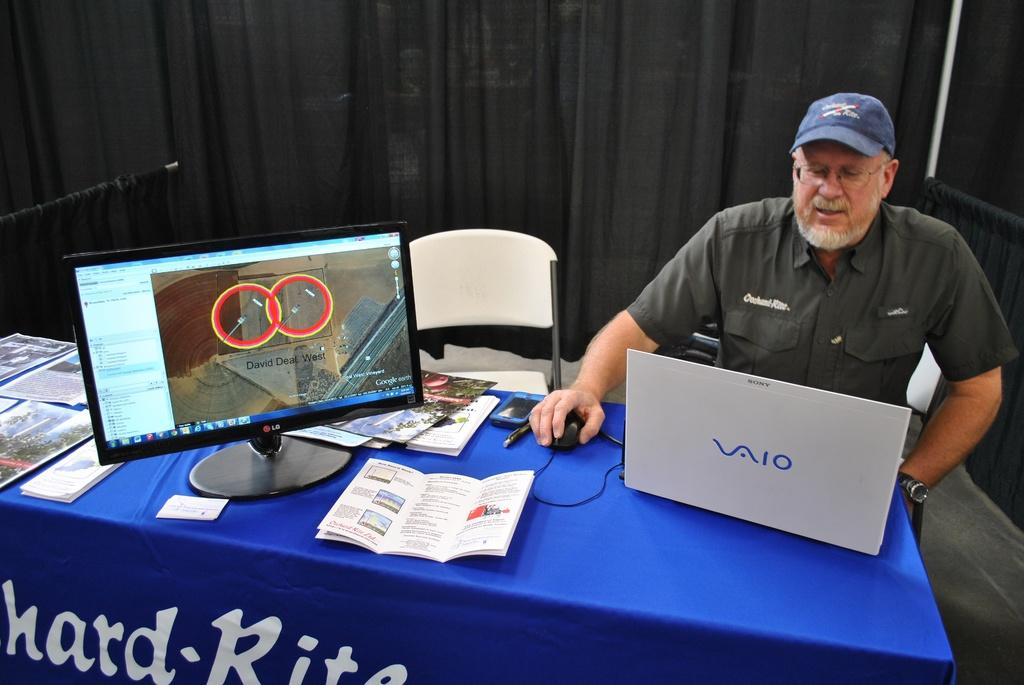What is the person in the image doing? The person is sitting on a chair. What can be seen on the person's head? The person is wearing a cap. What is in front of the person? There is a table in front of the person. What electronic devices are on the table? There is a laptop and a monitor on the table. What writing materials are on the table? There is a paper and a pen on the table. What communication device is on the table? There is a mobile on the table. What color is the curtain in the image? The curtain is black in color. What type of throne does the person sit on in the image? There is no throne present in the image; the person is sitting on a chair. What type of farming equipment can be seen in the image? There is no farming equipment present in the image. 